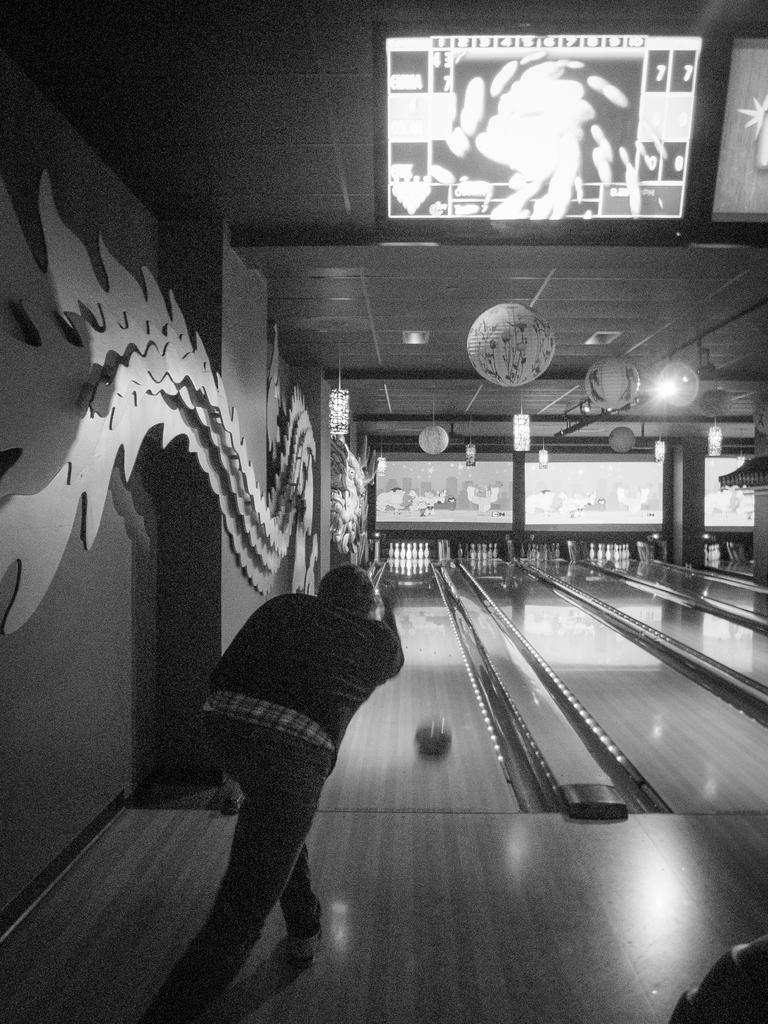Please provide a concise description of this image. This image is a black and white image. This image is taken indoors. At the bottom of the image there is a floor. On the left side of the image there is a wall with a carving and a man is standing on the floor and throwing a ball. In the middle of the image there is a bowling track. In the background there is a wall and there are a few paintings. At the top of the image there is a ceiling with a few lamps and there is a screen. 